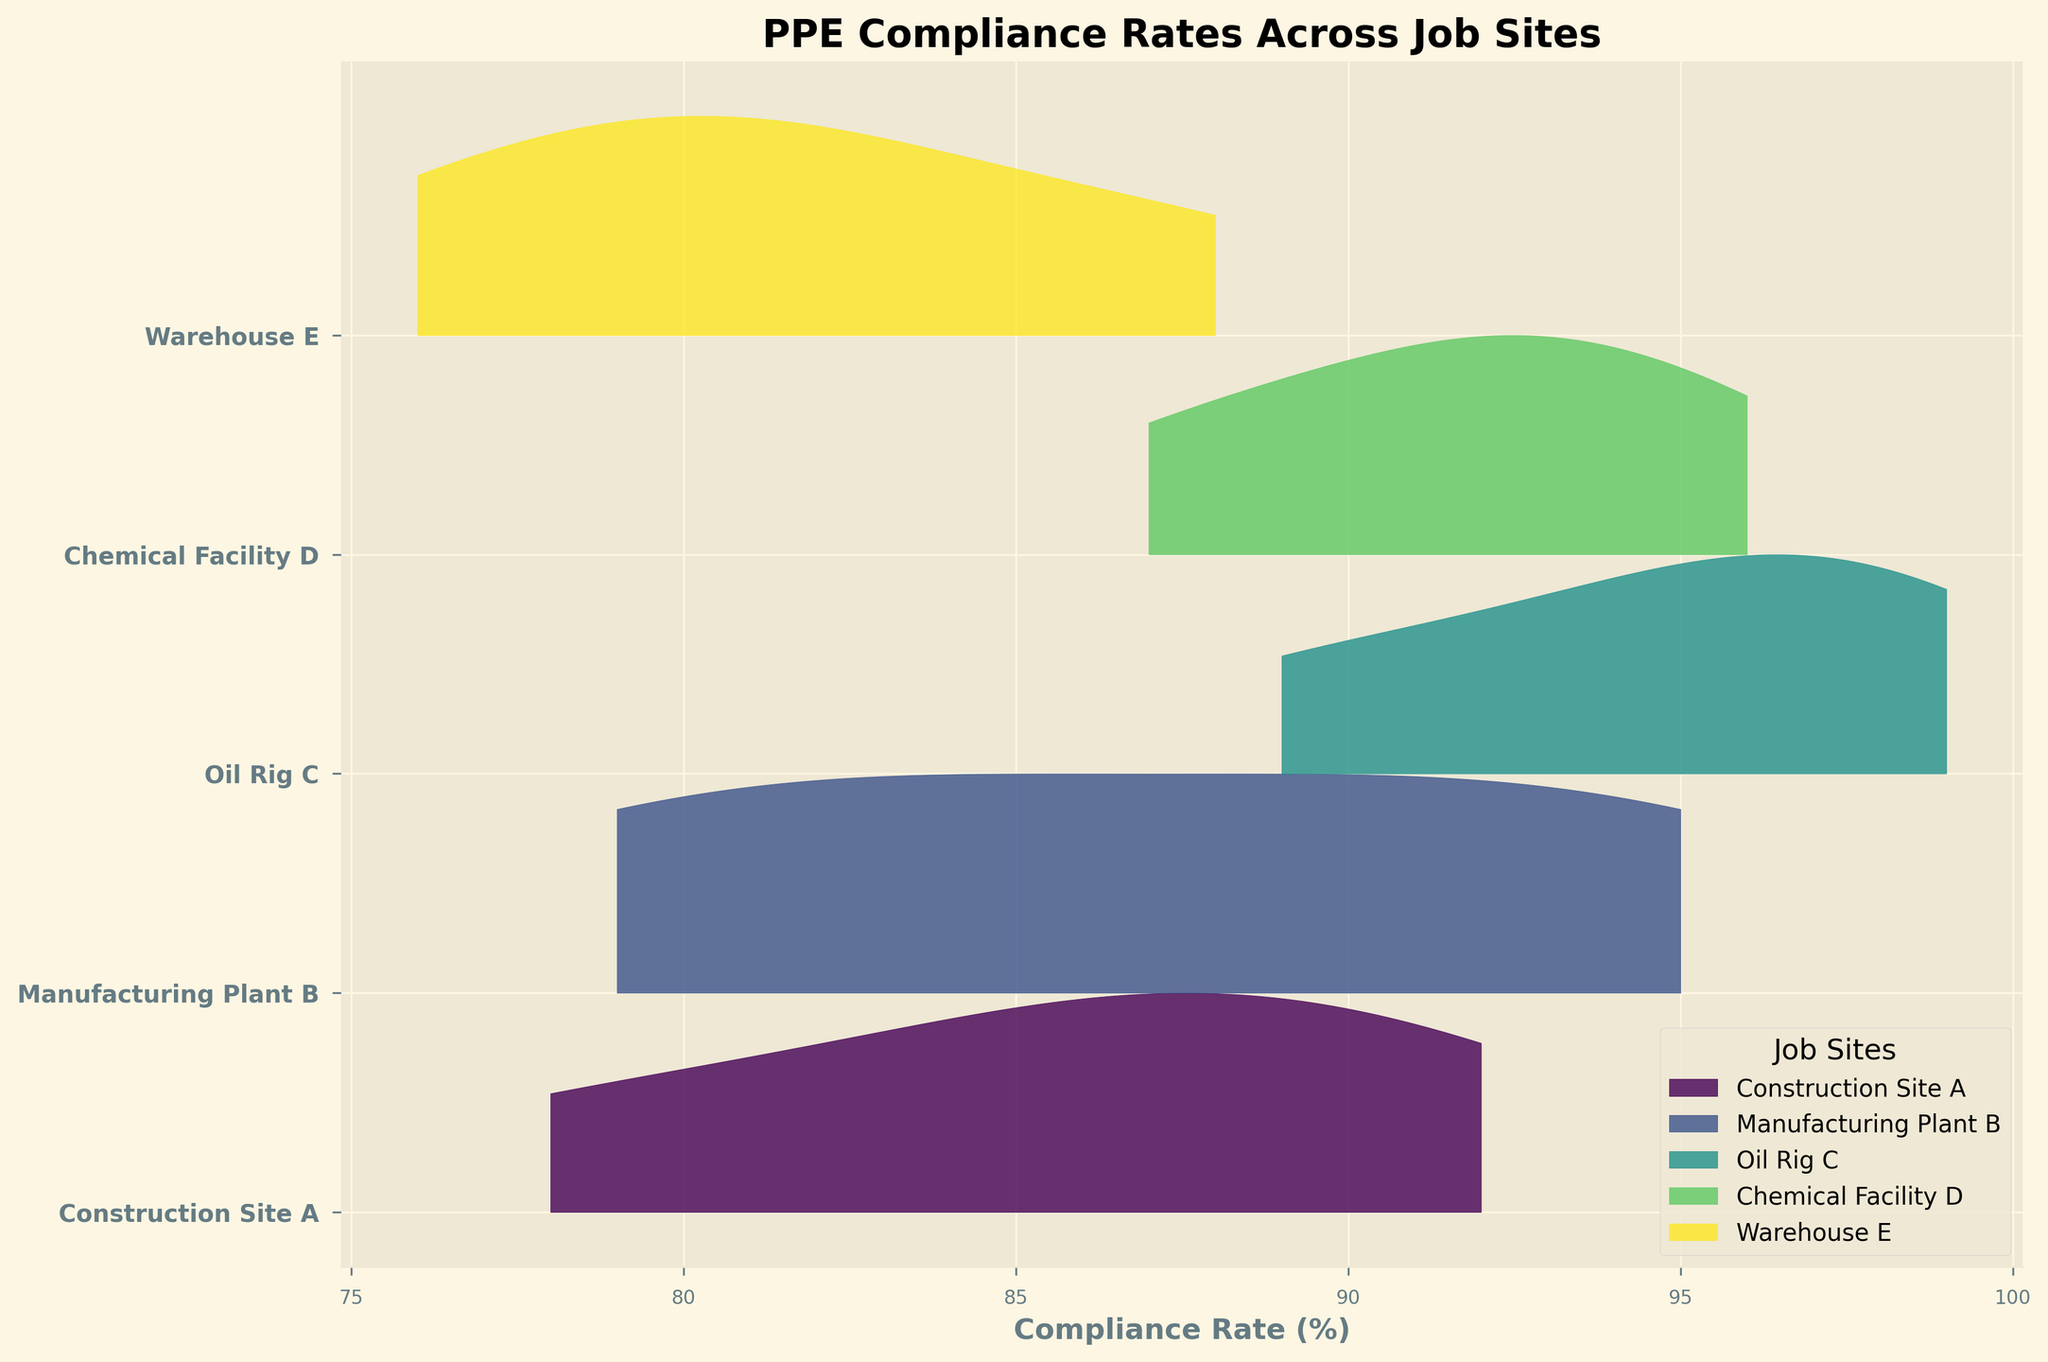What is the title of the plot? The title is typically located at the top of the plot and describes the overall theme or subject. In this case, it reads 'PPE Compliance Rates Across Job Sites.'
Answer: PPE Compliance Rates Across Job Sites What does the x-axis represent? The x-axis in this plot is labeled accordingly. It represents the 'Compliance Rate (%)', which measures the percentage of employees adhering to PPE usage protocols.
Answer: Compliance Rate (%) How many job sites are represented in the plot? The job sites are indicated by distinct ridgelines, with each ridgeline representing a different job site. By counting these, we find there are five: Construction Site A, Manufacturing Plant B, Oil Rig C, Chemical Facility D, and Warehouse E.
Answer: 5 Which job site has the highest peak in compliance rate? The height of the peaks can be visually compared to determine which job site has the highest compliance rates. Oil Rig C shows the highest peak, indicating the highest compliance.
Answer: Oil Rig C Which job site has the lowest minimum compliance rate? By observing the leftmost extent of each site's ridgeline, we can determine the site with the lowest minimum compliance rate. Warehouse E has the lowest minimum compliance rate, starting at about 76%.
Answer: Warehouse E What is the range of compliance rates for Manufacturing Plant B? The range can be determined by identifying the lowest and highest compliance rates for Manufacturing Plant B. The lowest rate is about 79%, and the highest is about 95%, so the range is 16%.
Answer: 16% Compare the compliance rate distributions of Construction Site A and Warehouse E. Which one appears more spread out? Comparing the width of the ridgelines, we can see that Construction Site A's compliance rates range from 78% to 92%, while Warehouse E's range from 76% to 88%. Construction Site A has a broader range and appears more spread out.
Answer: Construction Site A Which job site shows the narrowest compliance rate distribution? The narrowness of a ridgeline suggests a smaller range of compliance rates. The Oil Rig C has a compliance rate that is tightly grouped between 89% and 99%, which indicates a narrow distribution.
Answer: Oil Rig C Is there a job site where any compliance rate peaks above 95%? To determine this, we inspect the plot for peaks exceeding 95% compliance. Oil Rig C has peaks that rise above 95%.
Answer: Oil Rig C What is the approximate average compliance rate for Chemical Facility D? The average can be estimated by viewing where the main mass of the distribution is centered. The rates for Chemical Facility D appear to be centered between 87% and 96%, which averages roughly to 91.5%.
Answer: 91.5% 